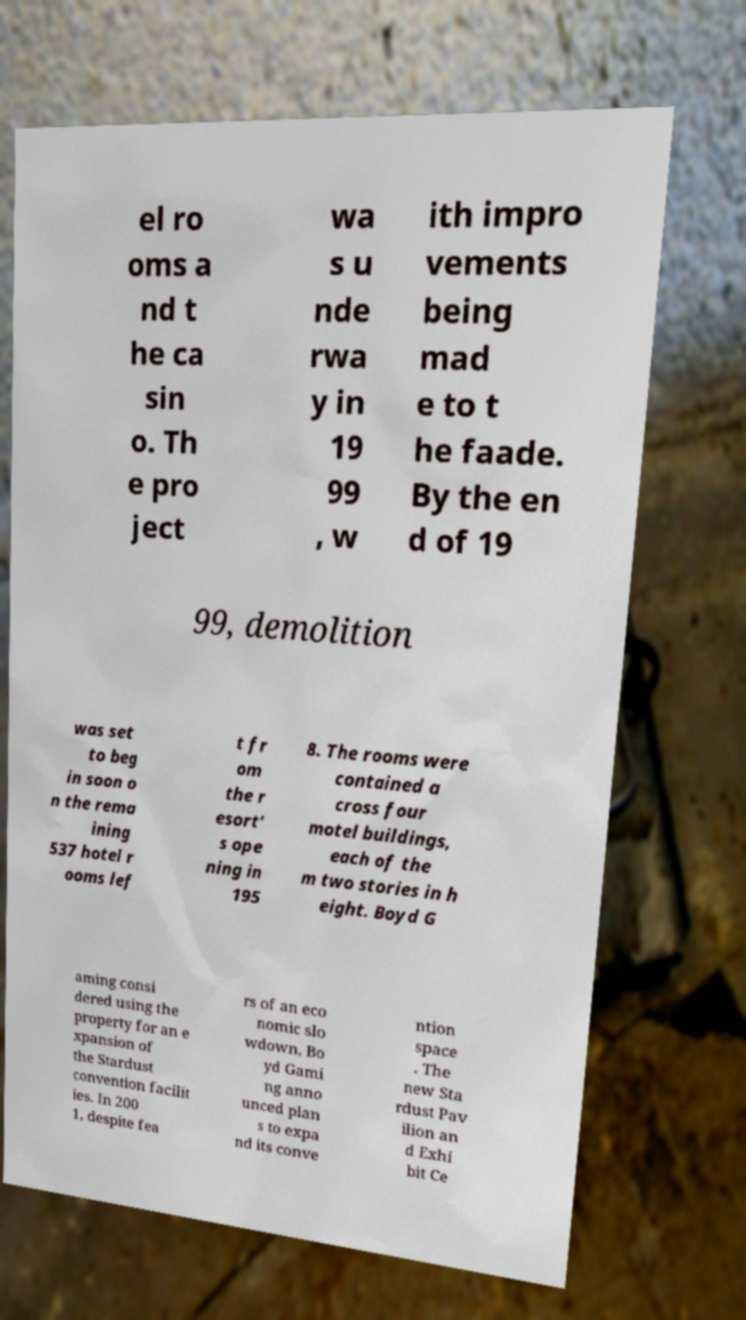Please identify and transcribe the text found in this image. el ro oms a nd t he ca sin o. Th e pro ject wa s u nde rwa y in 19 99 , w ith impro vements being mad e to t he faade. By the en d of 19 99, demolition was set to beg in soon o n the rema ining 537 hotel r ooms lef t fr om the r esort' s ope ning in 195 8. The rooms were contained a cross four motel buildings, each of the m two stories in h eight. Boyd G aming consi dered using the property for an e xpansion of the Stardust convention facilit ies. In 200 1, despite fea rs of an eco nomic slo wdown, Bo yd Gami ng anno unced plan s to expa nd its conve ntion space . The new Sta rdust Pav ilion an d Exhi bit Ce 